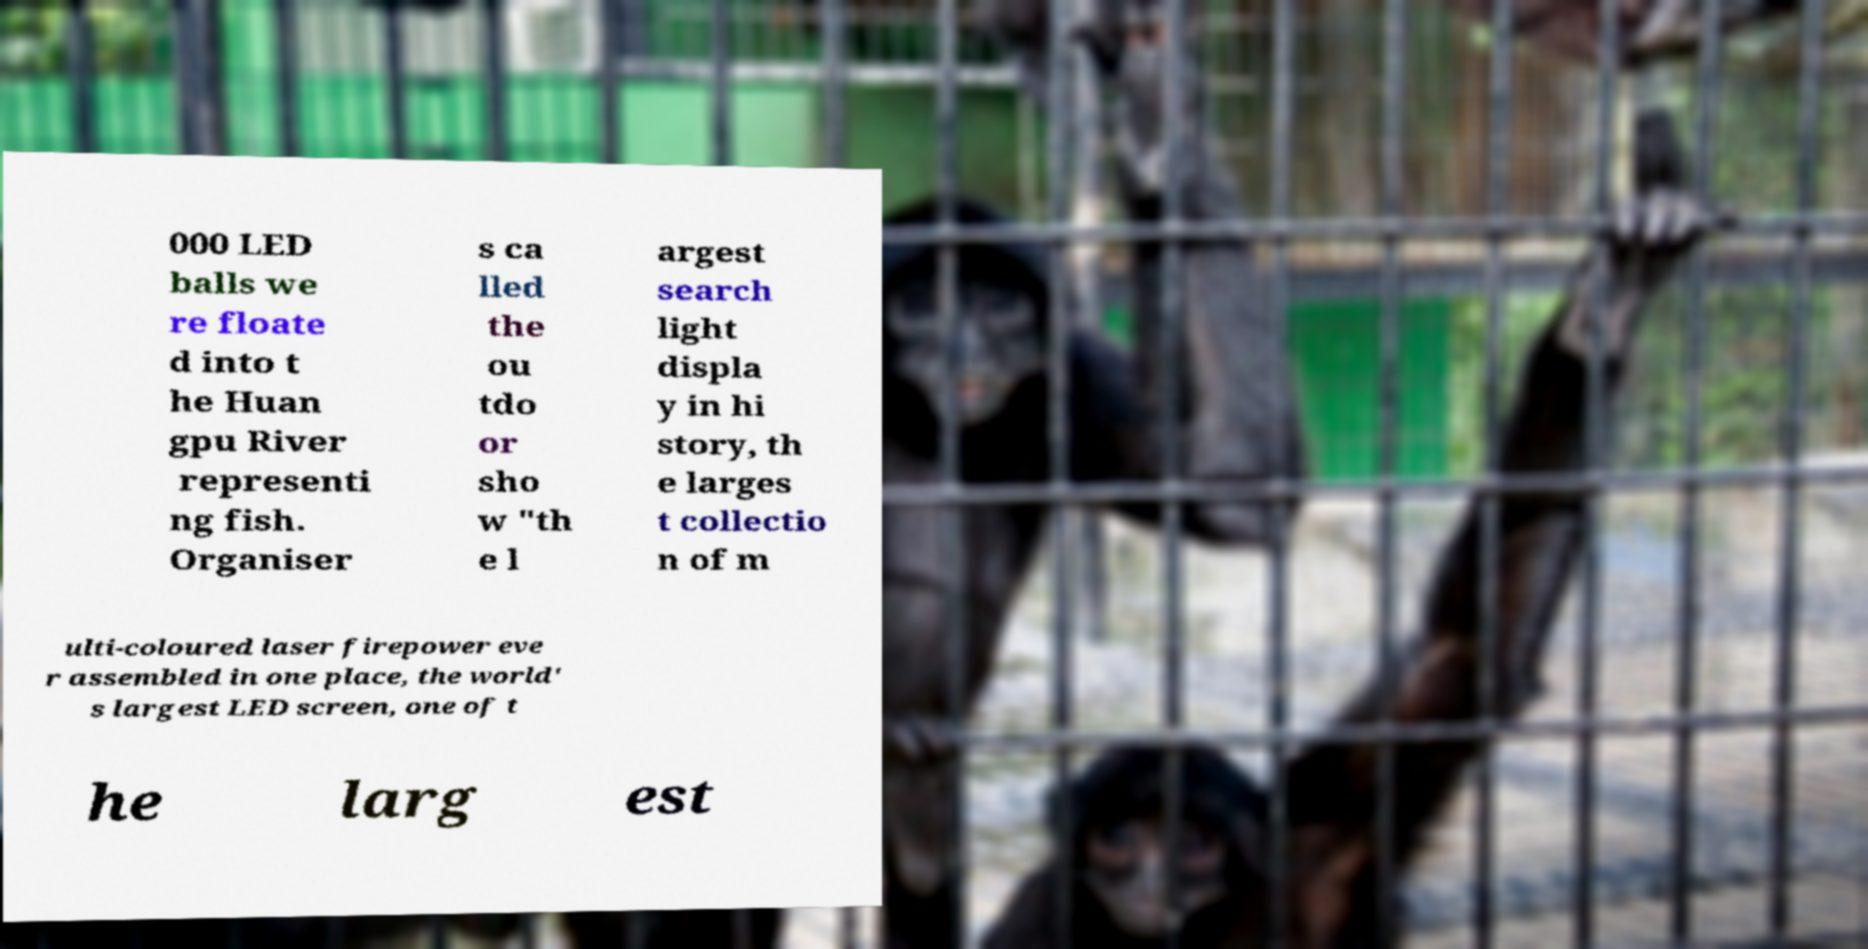Could you assist in decoding the text presented in this image and type it out clearly? 000 LED balls we re floate d into t he Huan gpu River representi ng fish. Organiser s ca lled the ou tdo or sho w "th e l argest search light displa y in hi story, th e larges t collectio n of m ulti-coloured laser firepower eve r assembled in one place, the world' s largest LED screen, one of t he larg est 